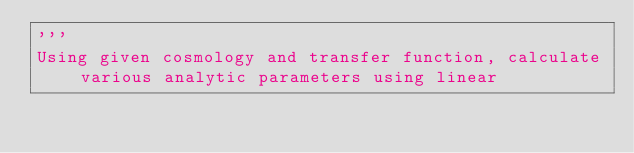Convert code to text. <code><loc_0><loc_0><loc_500><loc_500><_Python_>'''
Using given cosmology and transfer function, calculate various analytic parameters using linear</code> 